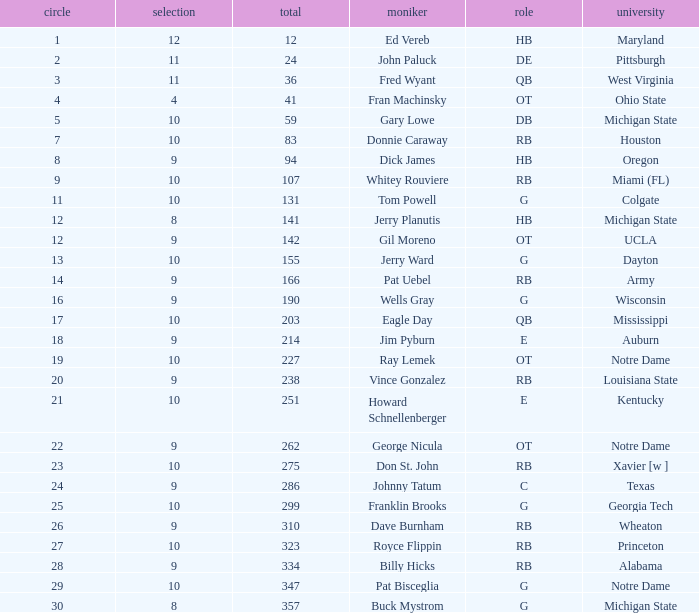Parse the table in full. {'header': ['circle', 'selection', 'total', 'moniker', 'role', 'university'], 'rows': [['1', '12', '12', 'Ed Vereb', 'HB', 'Maryland'], ['2', '11', '24', 'John Paluck', 'DE', 'Pittsburgh'], ['3', '11', '36', 'Fred Wyant', 'QB', 'West Virginia'], ['4', '4', '41', 'Fran Machinsky', 'OT', 'Ohio State'], ['5', '10', '59', 'Gary Lowe', 'DB', 'Michigan State'], ['7', '10', '83', 'Donnie Caraway', 'RB', 'Houston'], ['8', '9', '94', 'Dick James', 'HB', 'Oregon'], ['9', '10', '107', 'Whitey Rouviere', 'RB', 'Miami (FL)'], ['11', '10', '131', 'Tom Powell', 'G', 'Colgate'], ['12', '8', '141', 'Jerry Planutis', 'HB', 'Michigan State'], ['12', '9', '142', 'Gil Moreno', 'OT', 'UCLA'], ['13', '10', '155', 'Jerry Ward', 'G', 'Dayton'], ['14', '9', '166', 'Pat Uebel', 'RB', 'Army'], ['16', '9', '190', 'Wells Gray', 'G', 'Wisconsin'], ['17', '10', '203', 'Eagle Day', 'QB', 'Mississippi'], ['18', '9', '214', 'Jim Pyburn', 'E', 'Auburn'], ['19', '10', '227', 'Ray Lemek', 'OT', 'Notre Dame'], ['20', '9', '238', 'Vince Gonzalez', 'RB', 'Louisiana State'], ['21', '10', '251', 'Howard Schnellenberger', 'E', 'Kentucky'], ['22', '9', '262', 'George Nicula', 'OT', 'Notre Dame'], ['23', '10', '275', 'Don St. John', 'RB', 'Xavier [w ]'], ['24', '9', '286', 'Johnny Tatum', 'C', 'Texas'], ['25', '10', '299', 'Franklin Brooks', 'G', 'Georgia Tech'], ['26', '9', '310', 'Dave Burnham', 'RB', 'Wheaton'], ['27', '10', '323', 'Royce Flippin', 'RB', 'Princeton'], ['28', '9', '334', 'Billy Hicks', 'RB', 'Alabama'], ['29', '10', '347', 'Pat Bisceglia', 'G', 'Notre Dame'], ['30', '8', '357', 'Buck Mystrom', 'G', 'Michigan State']]} What is the total number of overall picks that were after pick 9 and went to Auburn College? 0.0. 